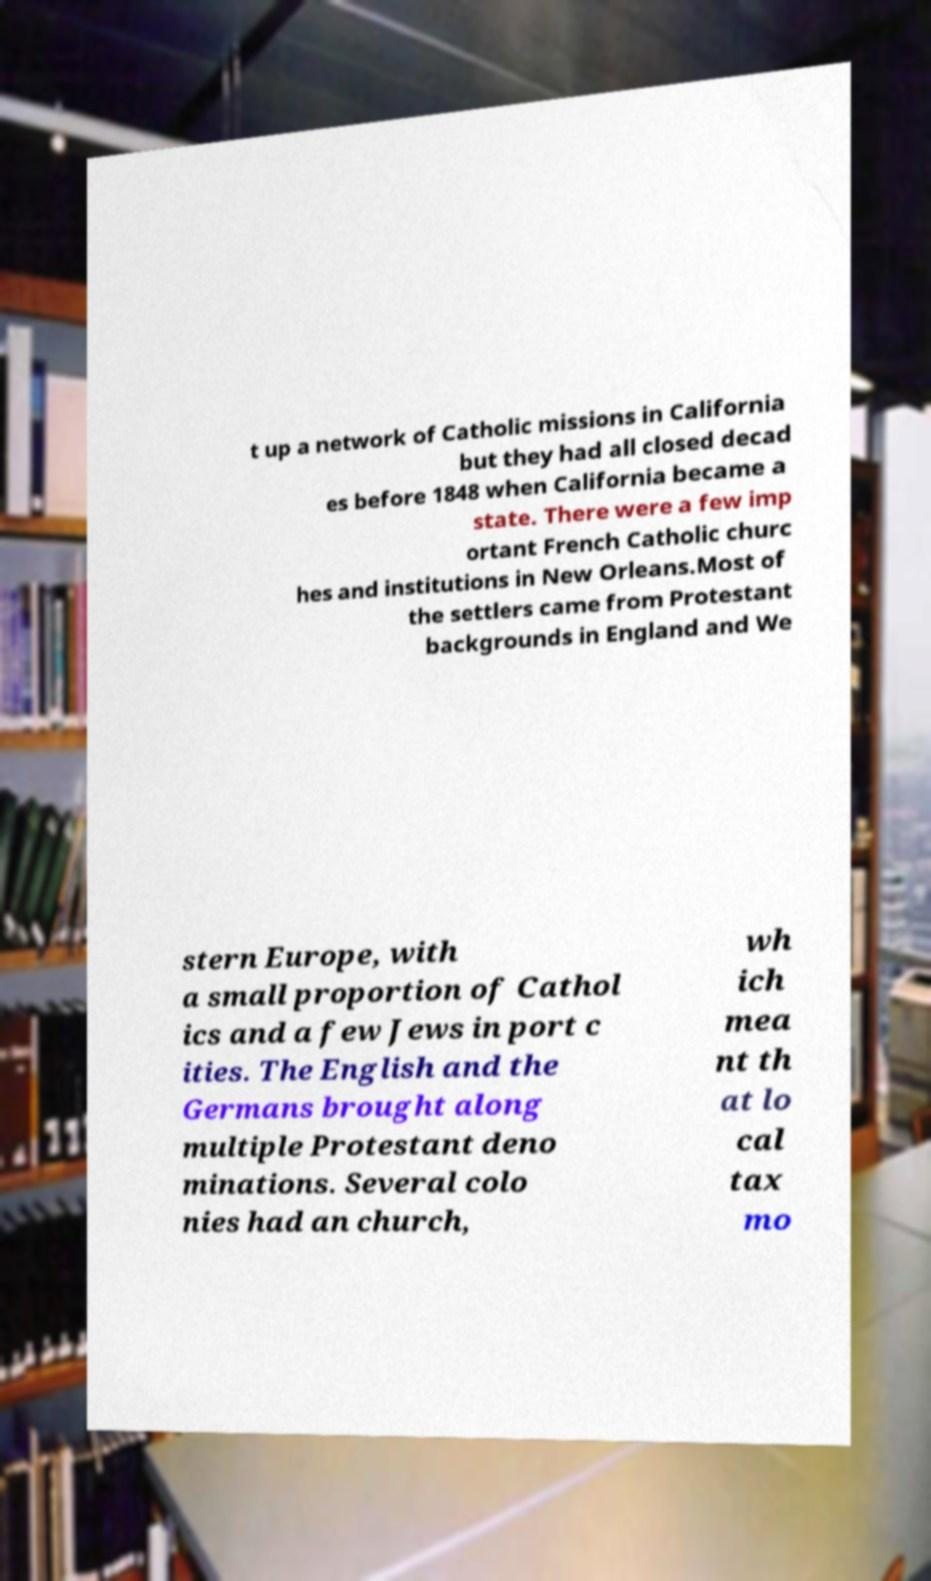What messages or text are displayed in this image? I need them in a readable, typed format. t up a network of Catholic missions in California but they had all closed decad es before 1848 when California became a state. There were a few imp ortant French Catholic churc hes and institutions in New Orleans.Most of the settlers came from Protestant backgrounds in England and We stern Europe, with a small proportion of Cathol ics and a few Jews in port c ities. The English and the Germans brought along multiple Protestant deno minations. Several colo nies had an church, wh ich mea nt th at lo cal tax mo 